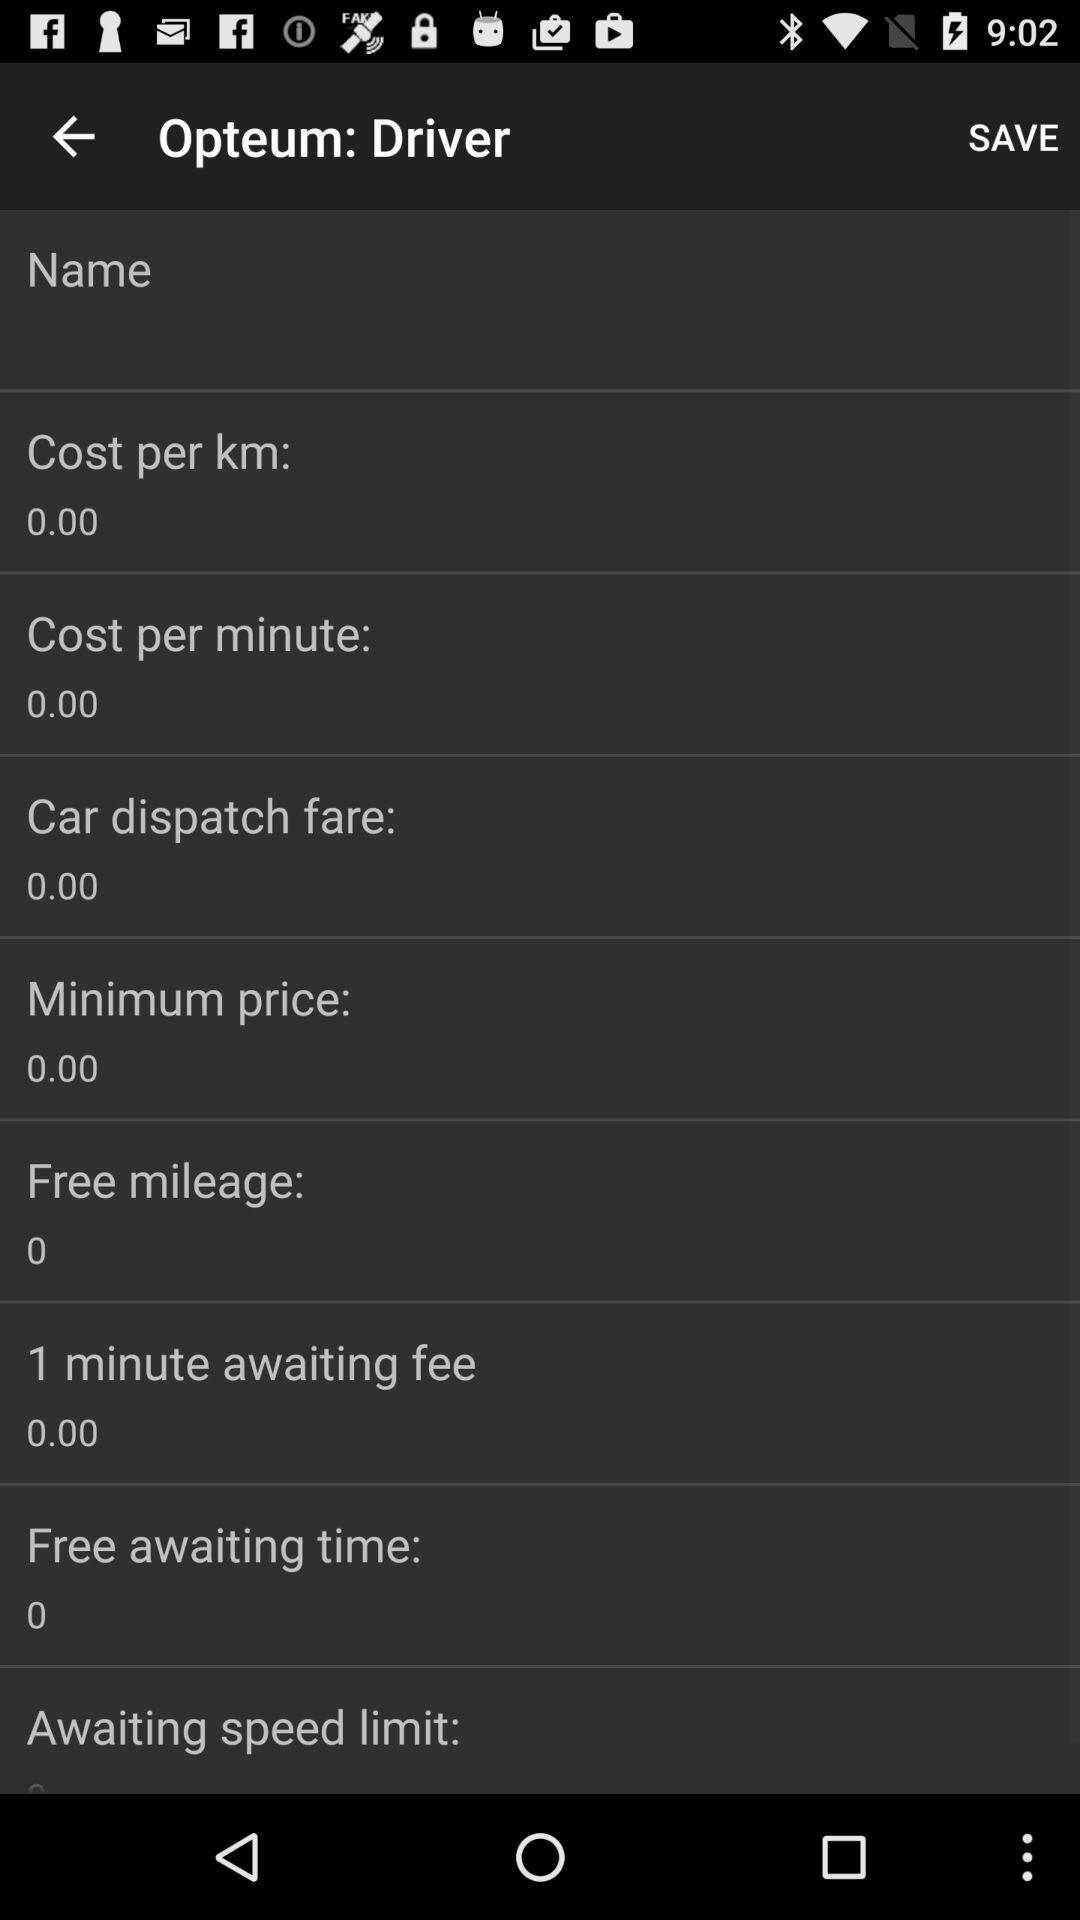How much is the cost per kilometre? The cost per kilometre is 0.00. 